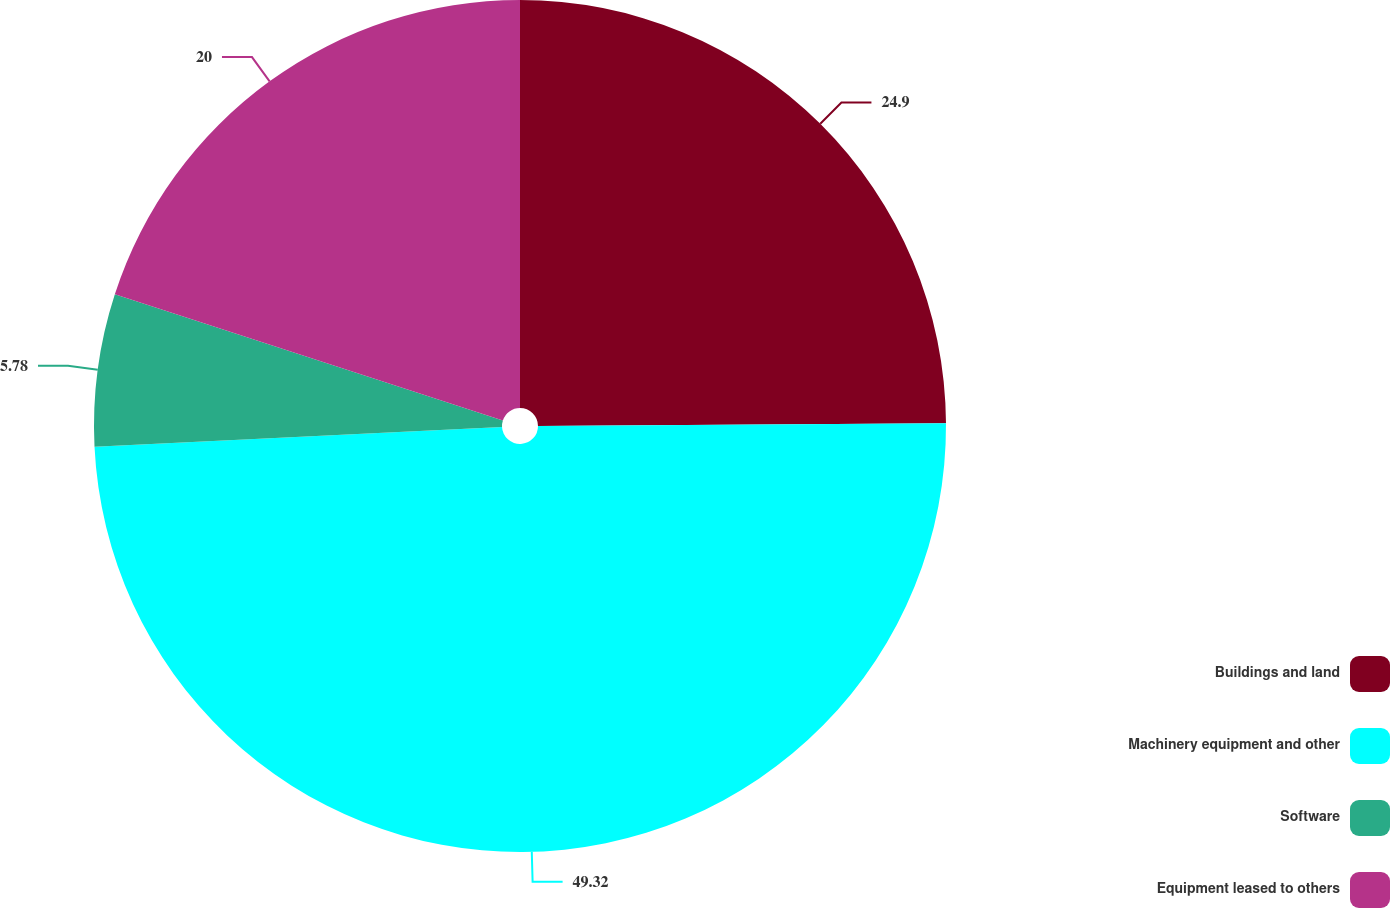Convert chart. <chart><loc_0><loc_0><loc_500><loc_500><pie_chart><fcel>Buildings and land<fcel>Machinery equipment and other<fcel>Software<fcel>Equipment leased to others<nl><fcel>24.9%<fcel>49.32%<fcel>5.78%<fcel>20.0%<nl></chart> 